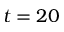<formula> <loc_0><loc_0><loc_500><loc_500>t = 2 0</formula> 